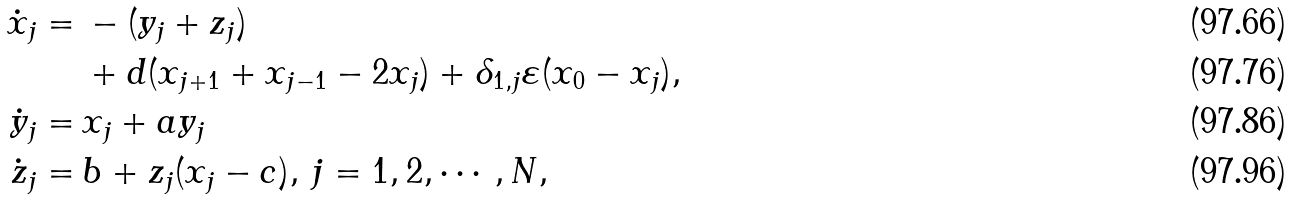Convert formula to latex. <formula><loc_0><loc_0><loc_500><loc_500>\dot { x } _ { j } = & \, - ( y _ { j } + z _ { j } ) \\ & \, + d ( x _ { j + 1 } + x _ { j - 1 } - 2 x _ { j } ) + \delta _ { 1 , j } \varepsilon ( x _ { 0 } - x _ { j } ) , \\ \dot { y } _ { j } = & \, x _ { j } + a y _ { j } \\ \dot { z } _ { j } = & \, b + z _ { j } ( x _ { j } - c ) , \, j = 1 , 2 , \cdots , N ,</formula> 